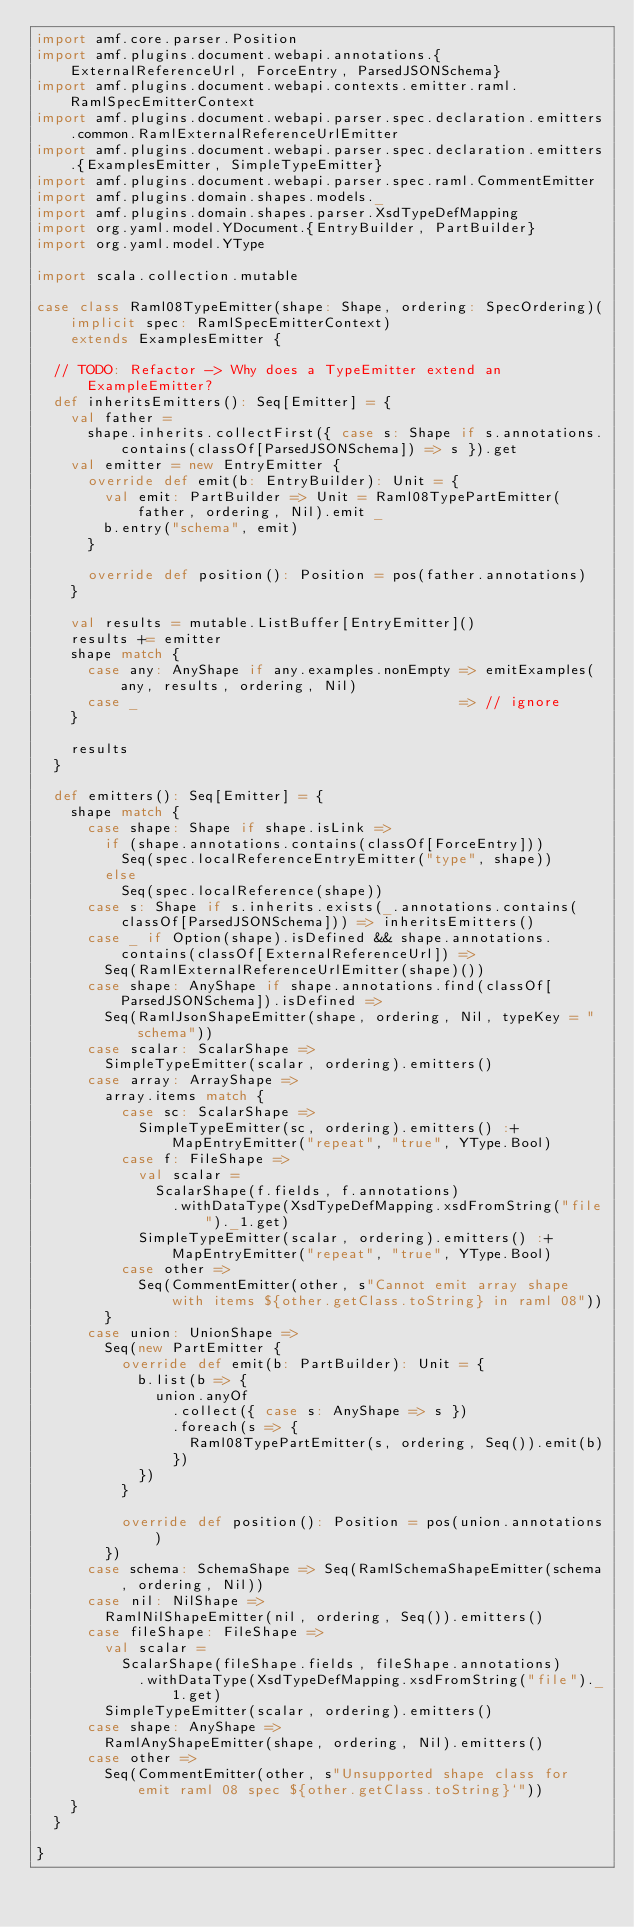Convert code to text. <code><loc_0><loc_0><loc_500><loc_500><_Scala_>import amf.core.parser.Position
import amf.plugins.document.webapi.annotations.{ExternalReferenceUrl, ForceEntry, ParsedJSONSchema}
import amf.plugins.document.webapi.contexts.emitter.raml.RamlSpecEmitterContext
import amf.plugins.document.webapi.parser.spec.declaration.emitters.common.RamlExternalReferenceUrlEmitter
import amf.plugins.document.webapi.parser.spec.declaration.emitters.{ExamplesEmitter, SimpleTypeEmitter}
import amf.plugins.document.webapi.parser.spec.raml.CommentEmitter
import amf.plugins.domain.shapes.models._
import amf.plugins.domain.shapes.parser.XsdTypeDefMapping
import org.yaml.model.YDocument.{EntryBuilder, PartBuilder}
import org.yaml.model.YType

import scala.collection.mutable

case class Raml08TypeEmitter(shape: Shape, ordering: SpecOrdering)(implicit spec: RamlSpecEmitterContext)
    extends ExamplesEmitter {

  // TODO: Refactor -> Why does a TypeEmitter extend an ExampleEmitter?
  def inheritsEmitters(): Seq[Emitter] = {
    val father =
      shape.inherits.collectFirst({ case s: Shape if s.annotations.contains(classOf[ParsedJSONSchema]) => s }).get
    val emitter = new EntryEmitter {
      override def emit(b: EntryBuilder): Unit = {
        val emit: PartBuilder => Unit = Raml08TypePartEmitter(father, ordering, Nil).emit _
        b.entry("schema", emit)
      }

      override def position(): Position = pos(father.annotations)
    }

    val results = mutable.ListBuffer[EntryEmitter]()
    results += emitter
    shape match {
      case any: AnyShape if any.examples.nonEmpty => emitExamples(any, results, ordering, Nil)
      case _                                      => // ignore
    }

    results
  }

  def emitters(): Seq[Emitter] = {
    shape match {
      case shape: Shape if shape.isLink =>
        if (shape.annotations.contains(classOf[ForceEntry]))
          Seq(spec.localReferenceEntryEmitter("type", shape))
        else
          Seq(spec.localReference(shape))
      case s: Shape if s.inherits.exists(_.annotations.contains(classOf[ParsedJSONSchema])) => inheritsEmitters()
      case _ if Option(shape).isDefined && shape.annotations.contains(classOf[ExternalReferenceUrl]) =>
        Seq(RamlExternalReferenceUrlEmitter(shape)())
      case shape: AnyShape if shape.annotations.find(classOf[ParsedJSONSchema]).isDefined =>
        Seq(RamlJsonShapeEmitter(shape, ordering, Nil, typeKey = "schema"))
      case scalar: ScalarShape =>
        SimpleTypeEmitter(scalar, ordering).emitters()
      case array: ArrayShape =>
        array.items match {
          case sc: ScalarShape =>
            SimpleTypeEmitter(sc, ordering).emitters() :+ MapEntryEmitter("repeat", "true", YType.Bool)
          case f: FileShape =>
            val scalar =
              ScalarShape(f.fields, f.annotations)
                .withDataType(XsdTypeDefMapping.xsdFromString("file")._1.get)
            SimpleTypeEmitter(scalar, ordering).emitters() :+ MapEntryEmitter("repeat", "true", YType.Bool)
          case other =>
            Seq(CommentEmitter(other, s"Cannot emit array shape with items ${other.getClass.toString} in raml 08"))
        }
      case union: UnionShape =>
        Seq(new PartEmitter {
          override def emit(b: PartBuilder): Unit = {
            b.list(b => {
              union.anyOf
                .collect({ case s: AnyShape => s })
                .foreach(s => {
                  Raml08TypePartEmitter(s, ordering, Seq()).emit(b)
                })
            })
          }

          override def position(): Position = pos(union.annotations)
        })
      case schema: SchemaShape => Seq(RamlSchemaShapeEmitter(schema, ordering, Nil))
      case nil: NilShape =>
        RamlNilShapeEmitter(nil, ordering, Seq()).emitters()
      case fileShape: FileShape =>
        val scalar =
          ScalarShape(fileShape.fields, fileShape.annotations)
            .withDataType(XsdTypeDefMapping.xsdFromString("file")._1.get)
        SimpleTypeEmitter(scalar, ordering).emitters()
      case shape: AnyShape =>
        RamlAnyShapeEmitter(shape, ordering, Nil).emitters()
      case other =>
        Seq(CommentEmitter(other, s"Unsupported shape class for emit raml 08 spec ${other.getClass.toString}`"))
    }
  }

}
</code> 